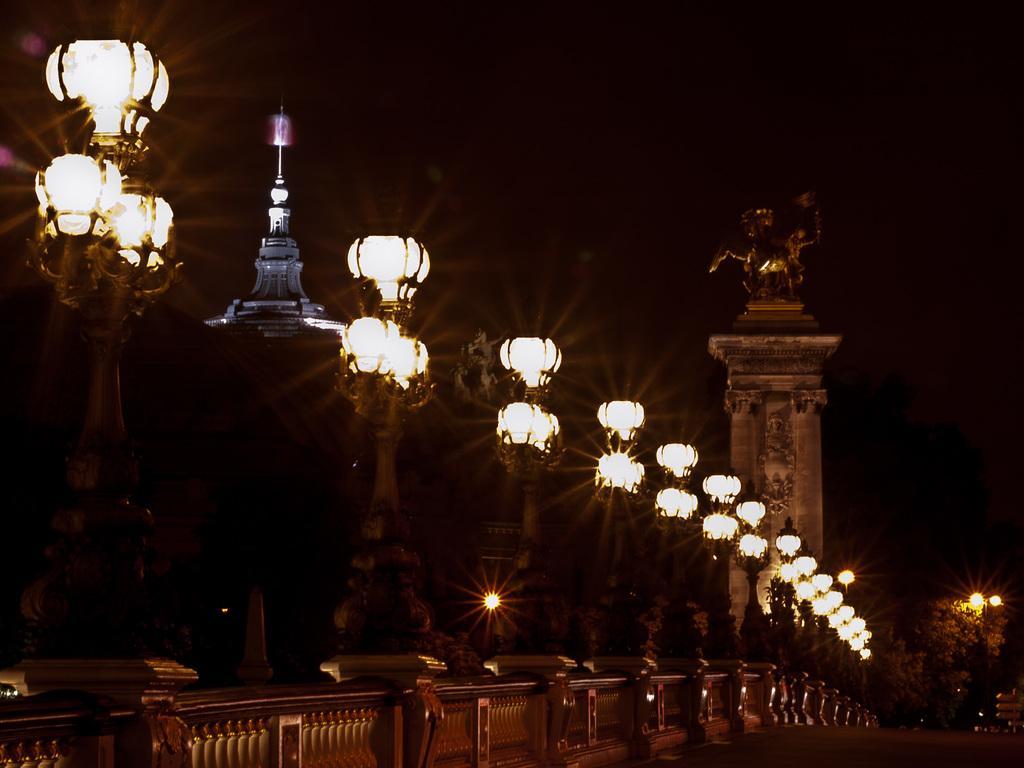Can you describe this image briefly? In this image I can see number of moles and number of lights. I can also see a sculpture on the right side and a building on the left side of the image. On the bottom right side of this image I can see a road and a tree. I can also see this image is little bit in dark. 